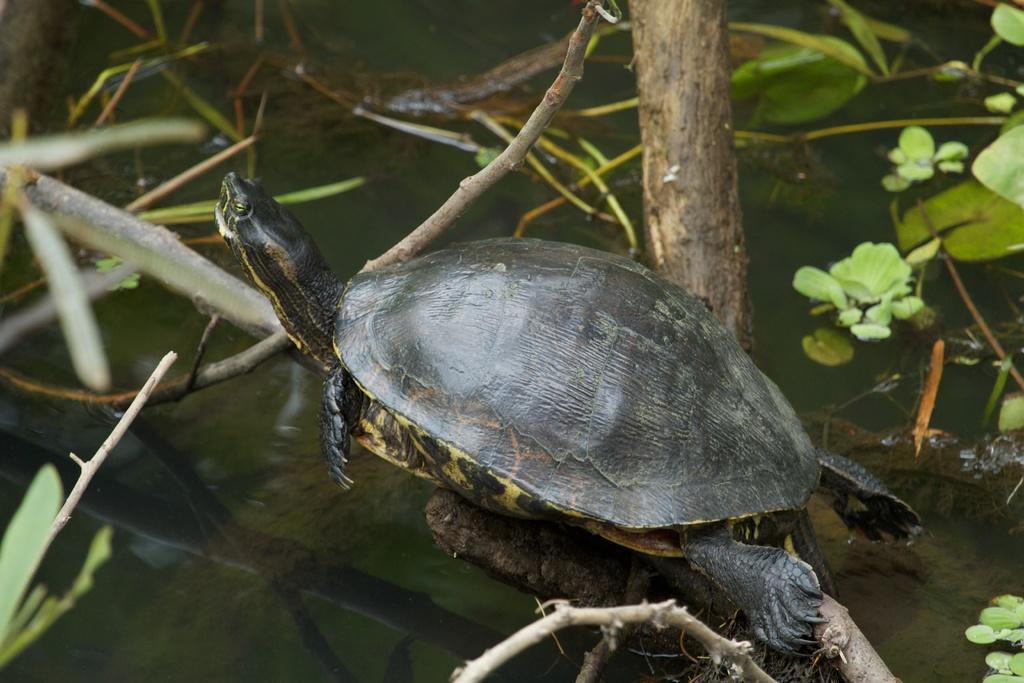Could you give a brief overview of what you see in this image? In this image I can see a turtle which is black and yellow in color on the branch of the tree and in the background I can see the water and few plants. 